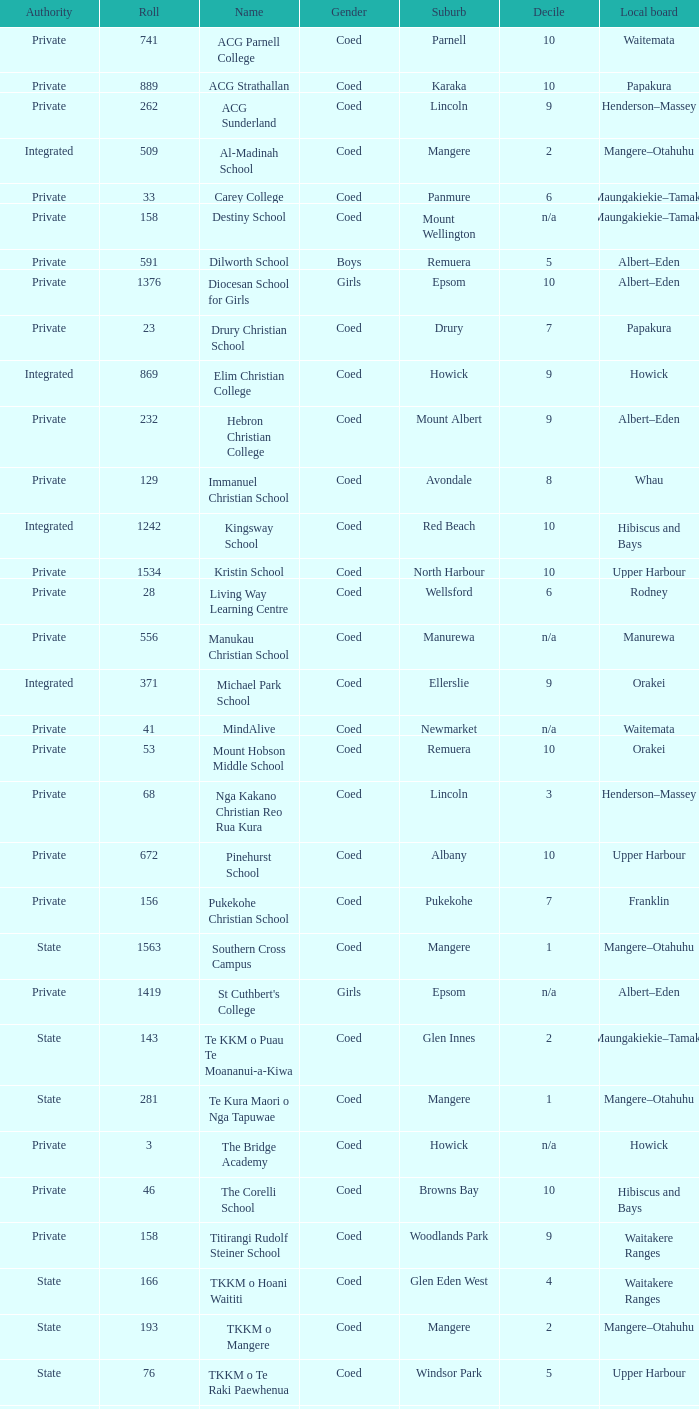What is the name when the local board is albert–eden, and a Decile of 9? Hebron Christian College. 